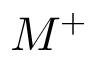Convert formula to latex. <formula><loc_0><loc_0><loc_500><loc_500>M ^ { + }</formula> 